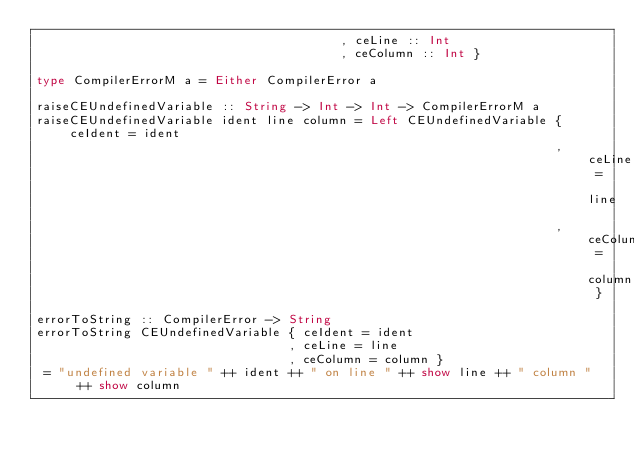Convert code to text. <code><loc_0><loc_0><loc_500><loc_500><_Haskell_>                                         , ceLine :: Int
                                         , ceColumn :: Int }

type CompilerErrorM a = Either CompilerError a

raiseCEUndefinedVariable :: String -> Int -> Int -> CompilerErrorM a
raiseCEUndefinedVariable ident line column = Left CEUndefinedVariable { ceIdent = ident
                                                                      , ceLine = line
                                                                      , ceColumn = column }

errorToString :: CompilerError -> String
errorToString CEUndefinedVariable { ceIdent = ident
                                  , ceLine = line
                                  , ceColumn = column }
 = "undefined variable " ++ ident ++ " on line " ++ show line ++ " column " ++ show column
</code> 